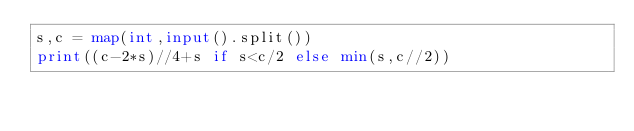Convert code to text. <code><loc_0><loc_0><loc_500><loc_500><_Python_>s,c = map(int,input().split())
print((c-2*s)//4+s if s<c/2 else min(s,c//2))</code> 